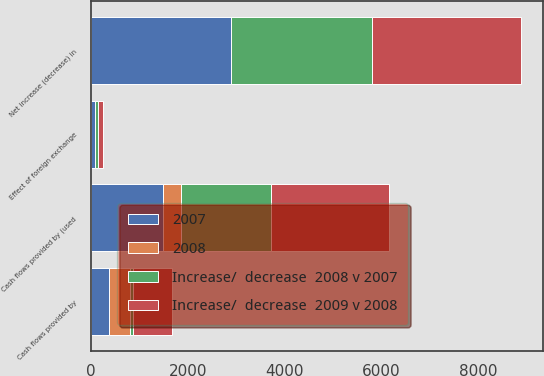Convert chart to OTSL. <chart><loc_0><loc_0><loc_500><loc_500><stacked_bar_chart><ecel><fcel>Cash flows provided by<fcel>Cash flows provided by (used<fcel>Effect of foreign exchange<fcel>Net increase (decrease) in<nl><fcel>2007<fcel>379<fcel>1488<fcel>72<fcel>2896<nl><fcel>2008<fcel>431<fcel>371<fcel>2<fcel>6<nl><fcel>Increase/  decrease  2009 v 2008<fcel>804<fcel>2437<fcel>91<fcel>3086<nl><fcel>Increase/  decrease  2008 v 2007<fcel>52<fcel>1859<fcel>74<fcel>2902<nl></chart> 